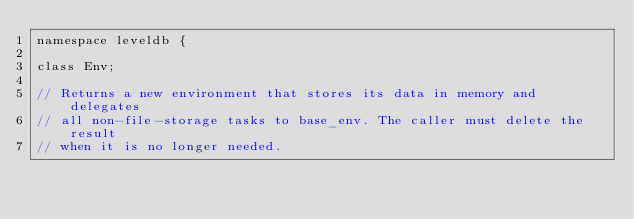<code> <loc_0><loc_0><loc_500><loc_500><_C_>namespace leveldb {

class Env;

// Returns a new environment that stores its data in memory and delegates
// all non-file-storage tasks to base_env. The caller must delete the result
// when it is no longer needed.</code> 